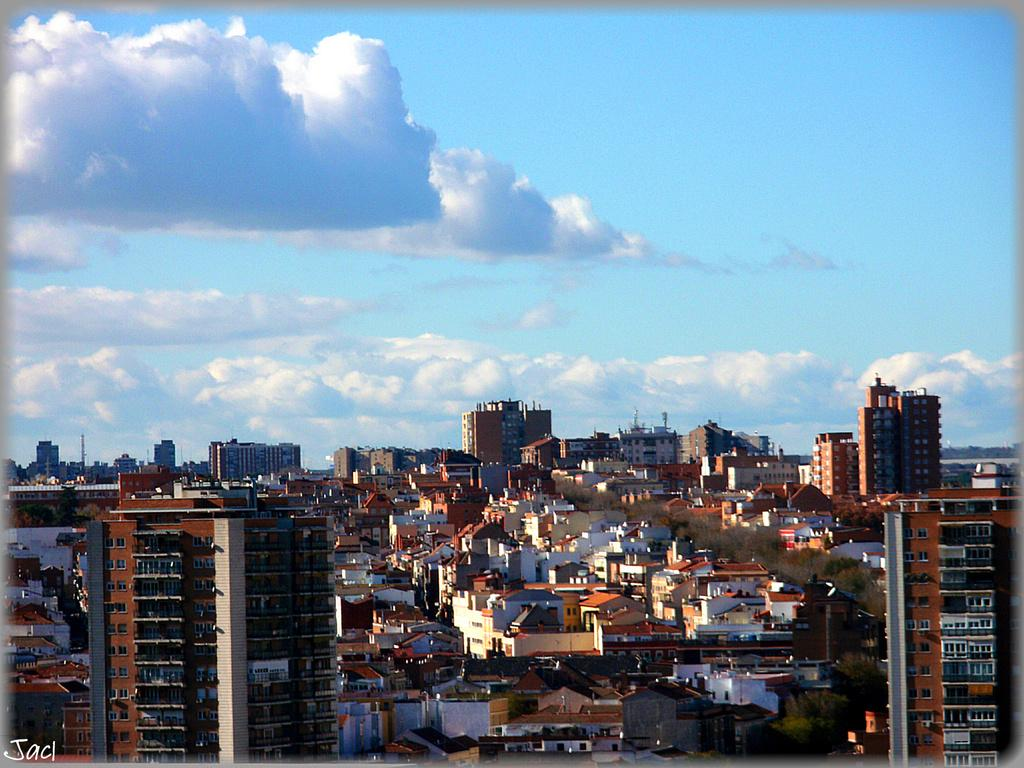What type of structures can be seen in the image? There are buildings in the image. What other natural elements are present in the image? There are trees in the image. What can be seen in the background of the image? Clouds and the sky are visible in the background of the image. Is there any indication of a watermark in the image? Yes, there is a watermark in the image. What type of ghost is visible in the image? There is no ghost present in the image. What committee is responsible for the design of the buildings in the image? There is no information about a committee responsible for the design of the buildings in the image. 